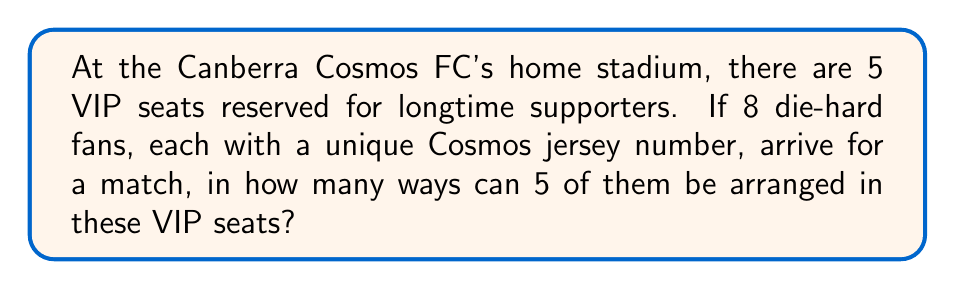What is the answer to this math problem? Let's approach this step-by-step:

1) First, we need to choose 5 fans out of the 8 to sit in the VIP seats. This is a combination problem, as the order of selection doesn't matter at this stage.

   The number of ways to choose 5 fans out of 8 is given by the combination formula:
   
   $$\binom{8}{5} = \frac{8!}{5!(8-5)!} = \frac{8!}{5!3!}$$

2) Now, for each of these selections, we need to arrange the 5 chosen fans in the 5 VIP seats. This is a permutation, as the order now matters.

   The number of ways to arrange 5 fans in 5 seats is simply 5!

3) By the multiplication principle, the total number of ways to both select and arrange the fans is:

   $$\binom{8}{5} \times 5!$$

4) Let's calculate this:
   
   $$\binom{8}{5} = \frac{8!}{5!3!} = \frac{8 \times 7 \times 6}{3 \times 2 \times 1} = 56$$
   
   $$56 \times 5! = 56 \times 120 = 6,720$$

Therefore, there are 6,720 ways to arrange 5 out of the 8 die-hard Canberra Cosmos FC fans in the 5 VIP seats.
Answer: 6,720 